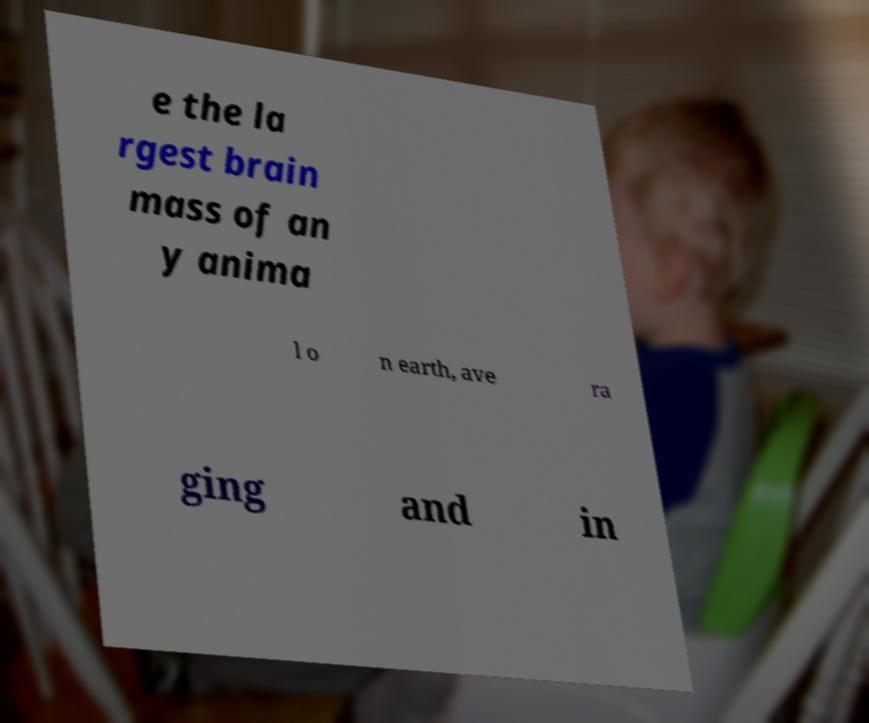For documentation purposes, I need the text within this image transcribed. Could you provide that? e the la rgest brain mass of an y anima l o n earth, ave ra ging and in 